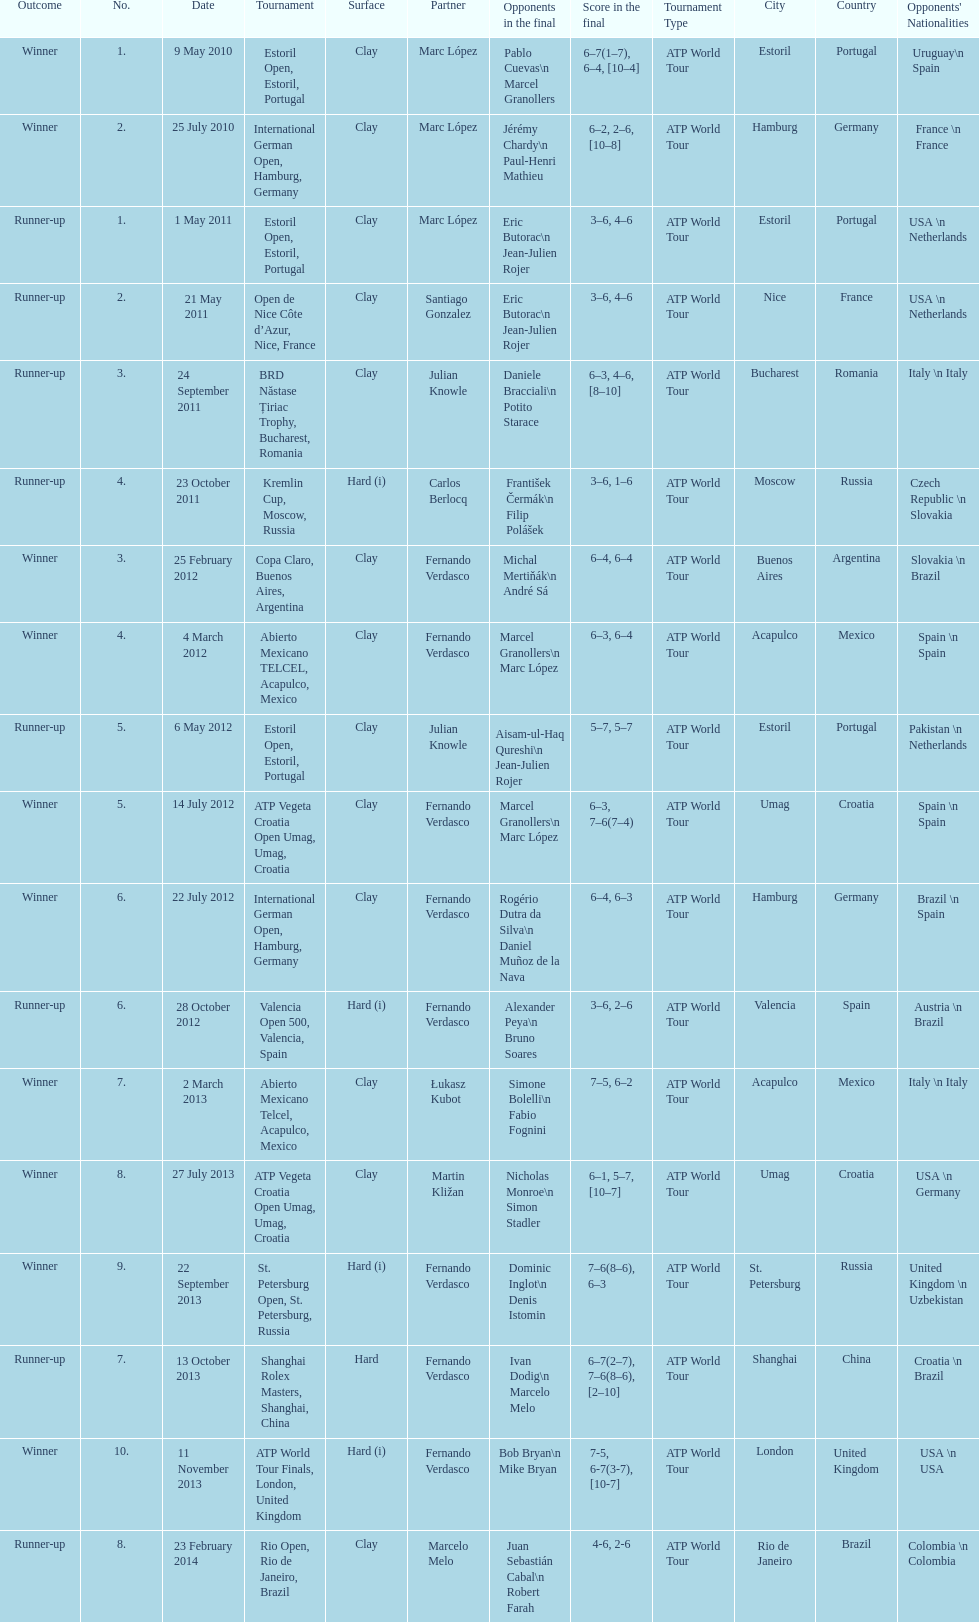What tournament was played after the kremlin cup? Copa Claro, Buenos Aires, Argentina. 